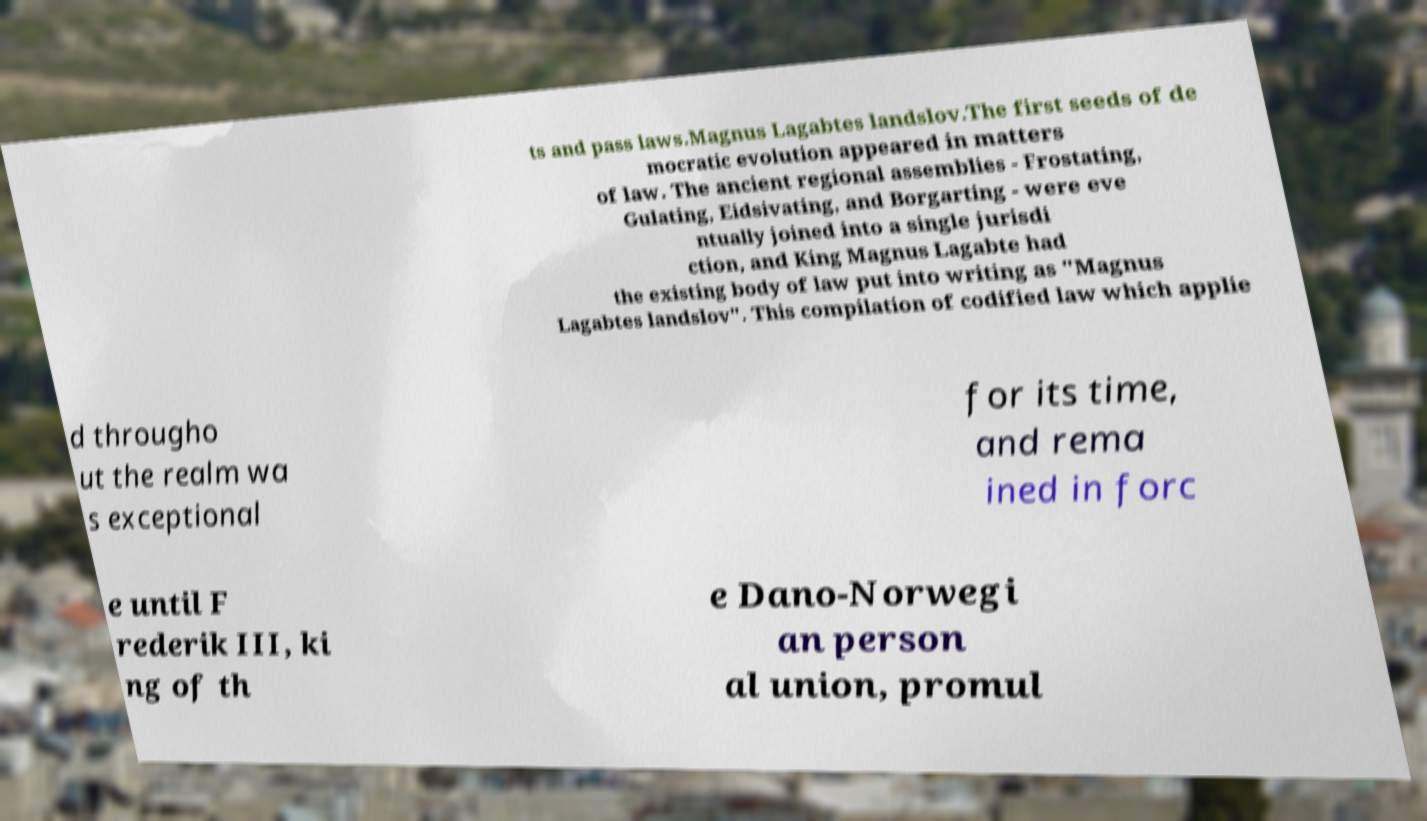Can you accurately transcribe the text from the provided image for me? ts and pass laws.Magnus Lagabtes landslov.The first seeds of de mocratic evolution appeared in matters of law. The ancient regional assemblies - Frostating, Gulating, Eidsivating, and Borgarting - were eve ntually joined into a single jurisdi ction, and King Magnus Lagabte had the existing body of law put into writing as "Magnus Lagabtes landslov". This compilation of codified law which applie d througho ut the realm wa s exceptional for its time, and rema ined in forc e until F rederik III, ki ng of th e Dano-Norwegi an person al union, promul 